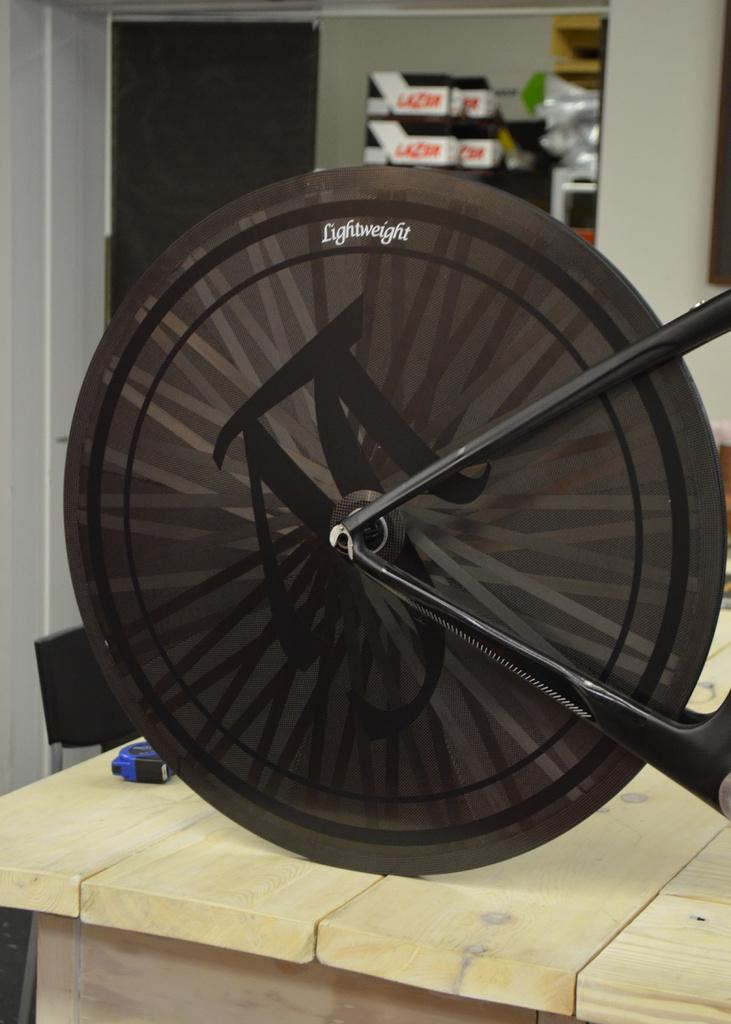What is the main object in the image? There is a cycle wheel in the image. What type of furniture is present in the image? There is a table and a chair in the image. What is used for storing items in the image? There is a rack with items in the image. What type of picture is hanging on the wall in the image? There is no wall or picture present in the image; it only features a cycle wheel, table, chair, and rack. 